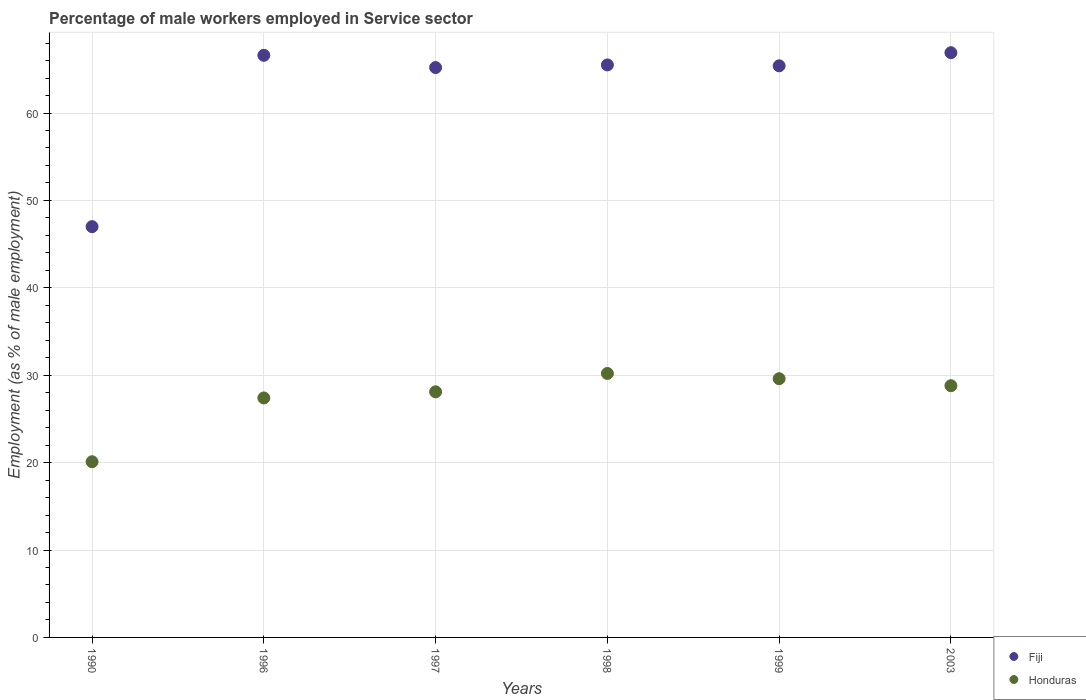How many different coloured dotlines are there?
Offer a very short reply. 2. Is the number of dotlines equal to the number of legend labels?
Provide a succinct answer. Yes. What is the percentage of male workers employed in Service sector in Fiji in 2003?
Give a very brief answer. 66.9. Across all years, what is the maximum percentage of male workers employed in Service sector in Fiji?
Give a very brief answer. 66.9. Across all years, what is the minimum percentage of male workers employed in Service sector in Fiji?
Your answer should be compact. 47. What is the total percentage of male workers employed in Service sector in Fiji in the graph?
Provide a succinct answer. 376.6. What is the difference between the percentage of male workers employed in Service sector in Fiji in 1990 and that in 1999?
Keep it short and to the point. -18.4. What is the difference between the percentage of male workers employed in Service sector in Honduras in 2003 and the percentage of male workers employed in Service sector in Fiji in 1990?
Provide a succinct answer. -18.2. What is the average percentage of male workers employed in Service sector in Fiji per year?
Your answer should be very brief. 62.77. In the year 1997, what is the difference between the percentage of male workers employed in Service sector in Honduras and percentage of male workers employed in Service sector in Fiji?
Your answer should be compact. -37.1. What is the ratio of the percentage of male workers employed in Service sector in Fiji in 1990 to that in 1996?
Your answer should be compact. 0.71. Is the percentage of male workers employed in Service sector in Fiji in 1996 less than that in 1999?
Ensure brevity in your answer.  No. What is the difference between the highest and the second highest percentage of male workers employed in Service sector in Fiji?
Keep it short and to the point. 0.3. What is the difference between the highest and the lowest percentage of male workers employed in Service sector in Fiji?
Your response must be concise. 19.9. In how many years, is the percentage of male workers employed in Service sector in Fiji greater than the average percentage of male workers employed in Service sector in Fiji taken over all years?
Ensure brevity in your answer.  5. Is the sum of the percentage of male workers employed in Service sector in Honduras in 1999 and 2003 greater than the maximum percentage of male workers employed in Service sector in Fiji across all years?
Your response must be concise. No. Are the values on the major ticks of Y-axis written in scientific E-notation?
Your answer should be very brief. No. Does the graph contain any zero values?
Your answer should be compact. No. How many legend labels are there?
Provide a short and direct response. 2. What is the title of the graph?
Keep it short and to the point. Percentage of male workers employed in Service sector. Does "Malawi" appear as one of the legend labels in the graph?
Your answer should be very brief. No. What is the label or title of the X-axis?
Give a very brief answer. Years. What is the label or title of the Y-axis?
Offer a very short reply. Employment (as % of male employment). What is the Employment (as % of male employment) in Fiji in 1990?
Offer a terse response. 47. What is the Employment (as % of male employment) in Honduras in 1990?
Ensure brevity in your answer.  20.1. What is the Employment (as % of male employment) in Fiji in 1996?
Give a very brief answer. 66.6. What is the Employment (as % of male employment) in Honduras in 1996?
Make the answer very short. 27.4. What is the Employment (as % of male employment) in Fiji in 1997?
Provide a short and direct response. 65.2. What is the Employment (as % of male employment) in Honduras in 1997?
Ensure brevity in your answer.  28.1. What is the Employment (as % of male employment) in Fiji in 1998?
Make the answer very short. 65.5. What is the Employment (as % of male employment) of Honduras in 1998?
Ensure brevity in your answer.  30.2. What is the Employment (as % of male employment) in Fiji in 1999?
Provide a short and direct response. 65.4. What is the Employment (as % of male employment) of Honduras in 1999?
Ensure brevity in your answer.  29.6. What is the Employment (as % of male employment) of Fiji in 2003?
Give a very brief answer. 66.9. What is the Employment (as % of male employment) of Honduras in 2003?
Provide a short and direct response. 28.8. Across all years, what is the maximum Employment (as % of male employment) of Fiji?
Offer a terse response. 66.9. Across all years, what is the maximum Employment (as % of male employment) of Honduras?
Provide a succinct answer. 30.2. Across all years, what is the minimum Employment (as % of male employment) in Fiji?
Ensure brevity in your answer.  47. Across all years, what is the minimum Employment (as % of male employment) of Honduras?
Keep it short and to the point. 20.1. What is the total Employment (as % of male employment) of Fiji in the graph?
Your answer should be compact. 376.6. What is the total Employment (as % of male employment) in Honduras in the graph?
Ensure brevity in your answer.  164.2. What is the difference between the Employment (as % of male employment) of Fiji in 1990 and that in 1996?
Offer a terse response. -19.6. What is the difference between the Employment (as % of male employment) of Fiji in 1990 and that in 1997?
Offer a very short reply. -18.2. What is the difference between the Employment (as % of male employment) of Honduras in 1990 and that in 1997?
Give a very brief answer. -8. What is the difference between the Employment (as % of male employment) in Fiji in 1990 and that in 1998?
Make the answer very short. -18.5. What is the difference between the Employment (as % of male employment) of Honduras in 1990 and that in 1998?
Make the answer very short. -10.1. What is the difference between the Employment (as % of male employment) of Fiji in 1990 and that in 1999?
Ensure brevity in your answer.  -18.4. What is the difference between the Employment (as % of male employment) in Honduras in 1990 and that in 1999?
Your response must be concise. -9.5. What is the difference between the Employment (as % of male employment) in Fiji in 1990 and that in 2003?
Your answer should be very brief. -19.9. What is the difference between the Employment (as % of male employment) in Honduras in 1990 and that in 2003?
Provide a succinct answer. -8.7. What is the difference between the Employment (as % of male employment) of Fiji in 1996 and that in 1998?
Make the answer very short. 1.1. What is the difference between the Employment (as % of male employment) in Fiji in 1996 and that in 1999?
Provide a succinct answer. 1.2. What is the difference between the Employment (as % of male employment) of Fiji in 1997 and that in 1999?
Your response must be concise. -0.2. What is the difference between the Employment (as % of male employment) in Fiji in 1998 and that in 2003?
Give a very brief answer. -1.4. What is the difference between the Employment (as % of male employment) in Fiji in 1999 and that in 2003?
Provide a succinct answer. -1.5. What is the difference between the Employment (as % of male employment) of Honduras in 1999 and that in 2003?
Your answer should be very brief. 0.8. What is the difference between the Employment (as % of male employment) of Fiji in 1990 and the Employment (as % of male employment) of Honduras in 1996?
Offer a terse response. 19.6. What is the difference between the Employment (as % of male employment) of Fiji in 1990 and the Employment (as % of male employment) of Honduras in 1997?
Ensure brevity in your answer.  18.9. What is the difference between the Employment (as % of male employment) of Fiji in 1990 and the Employment (as % of male employment) of Honduras in 1998?
Offer a very short reply. 16.8. What is the difference between the Employment (as % of male employment) of Fiji in 1990 and the Employment (as % of male employment) of Honduras in 2003?
Ensure brevity in your answer.  18.2. What is the difference between the Employment (as % of male employment) in Fiji in 1996 and the Employment (as % of male employment) in Honduras in 1997?
Make the answer very short. 38.5. What is the difference between the Employment (as % of male employment) of Fiji in 1996 and the Employment (as % of male employment) of Honduras in 1998?
Provide a succinct answer. 36.4. What is the difference between the Employment (as % of male employment) in Fiji in 1996 and the Employment (as % of male employment) in Honduras in 2003?
Make the answer very short. 37.8. What is the difference between the Employment (as % of male employment) in Fiji in 1997 and the Employment (as % of male employment) in Honduras in 1998?
Ensure brevity in your answer.  35. What is the difference between the Employment (as % of male employment) in Fiji in 1997 and the Employment (as % of male employment) in Honduras in 1999?
Offer a terse response. 35.6. What is the difference between the Employment (as % of male employment) in Fiji in 1997 and the Employment (as % of male employment) in Honduras in 2003?
Keep it short and to the point. 36.4. What is the difference between the Employment (as % of male employment) in Fiji in 1998 and the Employment (as % of male employment) in Honduras in 1999?
Your answer should be very brief. 35.9. What is the difference between the Employment (as % of male employment) in Fiji in 1998 and the Employment (as % of male employment) in Honduras in 2003?
Provide a succinct answer. 36.7. What is the difference between the Employment (as % of male employment) of Fiji in 1999 and the Employment (as % of male employment) of Honduras in 2003?
Your response must be concise. 36.6. What is the average Employment (as % of male employment) of Fiji per year?
Your answer should be very brief. 62.77. What is the average Employment (as % of male employment) in Honduras per year?
Provide a succinct answer. 27.37. In the year 1990, what is the difference between the Employment (as % of male employment) of Fiji and Employment (as % of male employment) of Honduras?
Give a very brief answer. 26.9. In the year 1996, what is the difference between the Employment (as % of male employment) in Fiji and Employment (as % of male employment) in Honduras?
Ensure brevity in your answer.  39.2. In the year 1997, what is the difference between the Employment (as % of male employment) of Fiji and Employment (as % of male employment) of Honduras?
Ensure brevity in your answer.  37.1. In the year 1998, what is the difference between the Employment (as % of male employment) of Fiji and Employment (as % of male employment) of Honduras?
Keep it short and to the point. 35.3. In the year 1999, what is the difference between the Employment (as % of male employment) of Fiji and Employment (as % of male employment) of Honduras?
Your response must be concise. 35.8. In the year 2003, what is the difference between the Employment (as % of male employment) in Fiji and Employment (as % of male employment) in Honduras?
Your answer should be compact. 38.1. What is the ratio of the Employment (as % of male employment) in Fiji in 1990 to that in 1996?
Ensure brevity in your answer.  0.71. What is the ratio of the Employment (as % of male employment) of Honduras in 1990 to that in 1996?
Provide a succinct answer. 0.73. What is the ratio of the Employment (as % of male employment) in Fiji in 1990 to that in 1997?
Give a very brief answer. 0.72. What is the ratio of the Employment (as % of male employment) of Honduras in 1990 to that in 1997?
Your answer should be very brief. 0.72. What is the ratio of the Employment (as % of male employment) of Fiji in 1990 to that in 1998?
Your answer should be compact. 0.72. What is the ratio of the Employment (as % of male employment) of Honduras in 1990 to that in 1998?
Make the answer very short. 0.67. What is the ratio of the Employment (as % of male employment) of Fiji in 1990 to that in 1999?
Your answer should be very brief. 0.72. What is the ratio of the Employment (as % of male employment) in Honduras in 1990 to that in 1999?
Your response must be concise. 0.68. What is the ratio of the Employment (as % of male employment) of Fiji in 1990 to that in 2003?
Your response must be concise. 0.7. What is the ratio of the Employment (as % of male employment) of Honduras in 1990 to that in 2003?
Offer a very short reply. 0.7. What is the ratio of the Employment (as % of male employment) in Fiji in 1996 to that in 1997?
Your answer should be compact. 1.02. What is the ratio of the Employment (as % of male employment) of Honduras in 1996 to that in 1997?
Offer a terse response. 0.98. What is the ratio of the Employment (as % of male employment) in Fiji in 1996 to that in 1998?
Provide a short and direct response. 1.02. What is the ratio of the Employment (as % of male employment) in Honduras in 1996 to that in 1998?
Ensure brevity in your answer.  0.91. What is the ratio of the Employment (as % of male employment) in Fiji in 1996 to that in 1999?
Provide a succinct answer. 1.02. What is the ratio of the Employment (as % of male employment) of Honduras in 1996 to that in 1999?
Your answer should be compact. 0.93. What is the ratio of the Employment (as % of male employment) in Honduras in 1996 to that in 2003?
Keep it short and to the point. 0.95. What is the ratio of the Employment (as % of male employment) in Honduras in 1997 to that in 1998?
Your response must be concise. 0.93. What is the ratio of the Employment (as % of male employment) in Fiji in 1997 to that in 1999?
Ensure brevity in your answer.  1. What is the ratio of the Employment (as % of male employment) of Honduras in 1997 to that in 1999?
Give a very brief answer. 0.95. What is the ratio of the Employment (as % of male employment) of Fiji in 1997 to that in 2003?
Offer a very short reply. 0.97. What is the ratio of the Employment (as % of male employment) in Honduras in 1997 to that in 2003?
Keep it short and to the point. 0.98. What is the ratio of the Employment (as % of male employment) of Fiji in 1998 to that in 1999?
Make the answer very short. 1. What is the ratio of the Employment (as % of male employment) of Honduras in 1998 to that in 1999?
Offer a terse response. 1.02. What is the ratio of the Employment (as % of male employment) in Fiji in 1998 to that in 2003?
Provide a succinct answer. 0.98. What is the ratio of the Employment (as % of male employment) in Honduras in 1998 to that in 2003?
Give a very brief answer. 1.05. What is the ratio of the Employment (as % of male employment) of Fiji in 1999 to that in 2003?
Offer a terse response. 0.98. What is the ratio of the Employment (as % of male employment) of Honduras in 1999 to that in 2003?
Your answer should be very brief. 1.03. What is the difference between the highest and the second highest Employment (as % of male employment) of Fiji?
Your answer should be very brief. 0.3. 